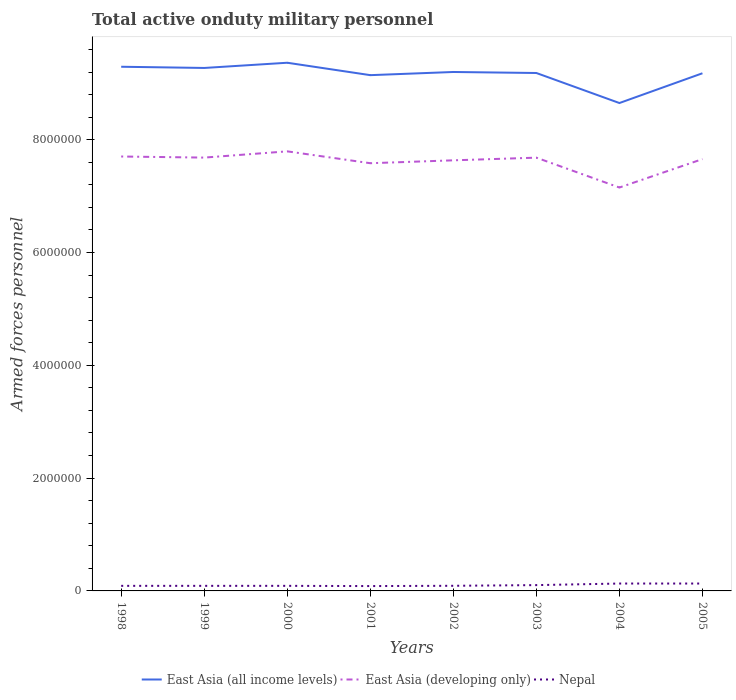Does the line corresponding to Nepal intersect with the line corresponding to East Asia (all income levels)?
Provide a short and direct response. No. Is the number of lines equal to the number of legend labels?
Make the answer very short. Yes. Across all years, what is the maximum number of armed forces personnel in East Asia (all income levels)?
Your answer should be compact. 8.65e+06. In which year was the number of armed forces personnel in East Asia (all income levels) maximum?
Give a very brief answer. 2004. What is the total number of armed forces personnel in East Asia (developing only) in the graph?
Ensure brevity in your answer.  1.12e+05. What is the difference between the highest and the second highest number of armed forces personnel in Nepal?
Offer a very short reply. 4.50e+04. What is the difference between the highest and the lowest number of armed forces personnel in East Asia (all income levels)?
Make the answer very short. 6. How many lines are there?
Ensure brevity in your answer.  3. How are the legend labels stacked?
Your answer should be compact. Horizontal. What is the title of the graph?
Provide a short and direct response. Total active onduty military personnel. What is the label or title of the X-axis?
Your response must be concise. Years. What is the label or title of the Y-axis?
Offer a terse response. Armed forces personnel. What is the Armed forces personnel in East Asia (all income levels) in 1998?
Keep it short and to the point. 9.29e+06. What is the Armed forces personnel of East Asia (developing only) in 1998?
Your answer should be compact. 7.70e+06. What is the Armed forces personnel in East Asia (all income levels) in 1999?
Offer a terse response. 9.27e+06. What is the Armed forces personnel of East Asia (developing only) in 1999?
Provide a short and direct response. 7.68e+06. What is the Armed forces personnel of Nepal in 1999?
Keep it short and to the point. 9.00e+04. What is the Armed forces personnel of East Asia (all income levels) in 2000?
Offer a very short reply. 9.36e+06. What is the Armed forces personnel in East Asia (developing only) in 2000?
Offer a terse response. 7.79e+06. What is the Armed forces personnel in East Asia (all income levels) in 2001?
Offer a very short reply. 9.14e+06. What is the Armed forces personnel of East Asia (developing only) in 2001?
Give a very brief answer. 7.58e+06. What is the Armed forces personnel in Nepal in 2001?
Provide a succinct answer. 8.60e+04. What is the Armed forces personnel of East Asia (all income levels) in 2002?
Provide a short and direct response. 9.20e+06. What is the Armed forces personnel of East Asia (developing only) in 2002?
Provide a succinct answer. 7.63e+06. What is the Armed forces personnel of Nepal in 2002?
Your response must be concise. 9.10e+04. What is the Armed forces personnel in East Asia (all income levels) in 2003?
Your answer should be compact. 9.18e+06. What is the Armed forces personnel in East Asia (developing only) in 2003?
Your response must be concise. 7.68e+06. What is the Armed forces personnel in Nepal in 2003?
Provide a succinct answer. 1.03e+05. What is the Armed forces personnel of East Asia (all income levels) in 2004?
Keep it short and to the point. 8.65e+06. What is the Armed forces personnel in East Asia (developing only) in 2004?
Your answer should be compact. 7.15e+06. What is the Armed forces personnel in Nepal in 2004?
Your answer should be compact. 1.31e+05. What is the Armed forces personnel of East Asia (all income levels) in 2005?
Your answer should be very brief. 9.18e+06. What is the Armed forces personnel in East Asia (developing only) in 2005?
Keep it short and to the point. 7.66e+06. What is the Armed forces personnel of Nepal in 2005?
Provide a short and direct response. 1.31e+05. Across all years, what is the maximum Armed forces personnel of East Asia (all income levels)?
Provide a succinct answer. 9.36e+06. Across all years, what is the maximum Armed forces personnel of East Asia (developing only)?
Your response must be concise. 7.79e+06. Across all years, what is the maximum Armed forces personnel of Nepal?
Ensure brevity in your answer.  1.31e+05. Across all years, what is the minimum Armed forces personnel in East Asia (all income levels)?
Give a very brief answer. 8.65e+06. Across all years, what is the minimum Armed forces personnel of East Asia (developing only)?
Keep it short and to the point. 7.15e+06. Across all years, what is the minimum Armed forces personnel in Nepal?
Your answer should be compact. 8.60e+04. What is the total Armed forces personnel in East Asia (all income levels) in the graph?
Ensure brevity in your answer.  7.33e+07. What is the total Armed forces personnel of East Asia (developing only) in the graph?
Your response must be concise. 6.09e+07. What is the total Armed forces personnel in Nepal in the graph?
Your answer should be very brief. 8.12e+05. What is the difference between the Armed forces personnel of East Asia (all income levels) in 1998 and that in 1999?
Offer a very short reply. 2.13e+04. What is the difference between the Armed forces personnel of East Asia (developing only) in 1998 and that in 1999?
Ensure brevity in your answer.  1.93e+04. What is the difference between the Armed forces personnel of East Asia (all income levels) in 1998 and that in 2000?
Offer a very short reply. -7.12e+04. What is the difference between the Armed forces personnel in East Asia (developing only) in 1998 and that in 2000?
Your answer should be very brief. -9.14e+04. What is the difference between the Armed forces personnel in East Asia (all income levels) in 1998 and that in 2001?
Ensure brevity in your answer.  1.49e+05. What is the difference between the Armed forces personnel in East Asia (developing only) in 1998 and that in 2001?
Provide a succinct answer. 1.19e+05. What is the difference between the Armed forces personnel of Nepal in 1998 and that in 2001?
Provide a succinct answer. 4000. What is the difference between the Armed forces personnel of East Asia (all income levels) in 1998 and that in 2002?
Offer a terse response. 9.26e+04. What is the difference between the Armed forces personnel in East Asia (developing only) in 1998 and that in 2002?
Your answer should be compact. 6.78e+04. What is the difference between the Armed forces personnel of Nepal in 1998 and that in 2002?
Offer a very short reply. -1000. What is the difference between the Armed forces personnel of East Asia (all income levels) in 1998 and that in 2003?
Your response must be concise. 1.11e+05. What is the difference between the Armed forces personnel of East Asia (developing only) in 1998 and that in 2003?
Offer a terse response. 2.04e+04. What is the difference between the Armed forces personnel of Nepal in 1998 and that in 2003?
Keep it short and to the point. -1.30e+04. What is the difference between the Armed forces personnel in East Asia (all income levels) in 1998 and that in 2004?
Ensure brevity in your answer.  6.43e+05. What is the difference between the Armed forces personnel of East Asia (developing only) in 1998 and that in 2004?
Keep it short and to the point. 5.50e+05. What is the difference between the Armed forces personnel of Nepal in 1998 and that in 2004?
Provide a short and direct response. -4.10e+04. What is the difference between the Armed forces personnel of East Asia (all income levels) in 1998 and that in 2005?
Offer a very short reply. 1.15e+05. What is the difference between the Armed forces personnel of East Asia (developing only) in 1998 and that in 2005?
Make the answer very short. 4.62e+04. What is the difference between the Armed forces personnel in Nepal in 1998 and that in 2005?
Your answer should be compact. -4.10e+04. What is the difference between the Armed forces personnel of East Asia (all income levels) in 1999 and that in 2000?
Provide a succinct answer. -9.25e+04. What is the difference between the Armed forces personnel of East Asia (developing only) in 1999 and that in 2000?
Provide a short and direct response. -1.11e+05. What is the difference between the Armed forces personnel in Nepal in 1999 and that in 2000?
Provide a succinct answer. 0. What is the difference between the Armed forces personnel of East Asia (all income levels) in 1999 and that in 2001?
Offer a terse response. 1.27e+05. What is the difference between the Armed forces personnel of East Asia (developing only) in 1999 and that in 2001?
Your response must be concise. 9.96e+04. What is the difference between the Armed forces personnel in Nepal in 1999 and that in 2001?
Your response must be concise. 4000. What is the difference between the Armed forces personnel in East Asia (all income levels) in 1999 and that in 2002?
Keep it short and to the point. 7.13e+04. What is the difference between the Armed forces personnel in East Asia (developing only) in 1999 and that in 2002?
Ensure brevity in your answer.  4.84e+04. What is the difference between the Armed forces personnel of Nepal in 1999 and that in 2002?
Make the answer very short. -1000. What is the difference between the Armed forces personnel of East Asia (all income levels) in 1999 and that in 2003?
Offer a very short reply. 8.93e+04. What is the difference between the Armed forces personnel in East Asia (developing only) in 1999 and that in 2003?
Make the answer very short. 1050. What is the difference between the Armed forces personnel in Nepal in 1999 and that in 2003?
Provide a short and direct response. -1.30e+04. What is the difference between the Armed forces personnel in East Asia (all income levels) in 1999 and that in 2004?
Ensure brevity in your answer.  6.22e+05. What is the difference between the Armed forces personnel of East Asia (developing only) in 1999 and that in 2004?
Your response must be concise. 5.31e+05. What is the difference between the Armed forces personnel of Nepal in 1999 and that in 2004?
Keep it short and to the point. -4.10e+04. What is the difference between the Armed forces personnel of East Asia (all income levels) in 1999 and that in 2005?
Provide a succinct answer. 9.41e+04. What is the difference between the Armed forces personnel of East Asia (developing only) in 1999 and that in 2005?
Your answer should be compact. 2.68e+04. What is the difference between the Armed forces personnel in Nepal in 1999 and that in 2005?
Make the answer very short. -4.10e+04. What is the difference between the Armed forces personnel of East Asia (all income levels) in 2000 and that in 2001?
Your response must be concise. 2.20e+05. What is the difference between the Armed forces personnel of East Asia (developing only) in 2000 and that in 2001?
Provide a succinct answer. 2.10e+05. What is the difference between the Armed forces personnel in Nepal in 2000 and that in 2001?
Your answer should be very brief. 4000. What is the difference between the Armed forces personnel in East Asia (all income levels) in 2000 and that in 2002?
Offer a very short reply. 1.64e+05. What is the difference between the Armed forces personnel in East Asia (developing only) in 2000 and that in 2002?
Your answer should be compact. 1.59e+05. What is the difference between the Armed forces personnel of Nepal in 2000 and that in 2002?
Your response must be concise. -1000. What is the difference between the Armed forces personnel of East Asia (all income levels) in 2000 and that in 2003?
Ensure brevity in your answer.  1.82e+05. What is the difference between the Armed forces personnel in East Asia (developing only) in 2000 and that in 2003?
Provide a succinct answer. 1.12e+05. What is the difference between the Armed forces personnel in Nepal in 2000 and that in 2003?
Provide a short and direct response. -1.30e+04. What is the difference between the Armed forces personnel of East Asia (all income levels) in 2000 and that in 2004?
Make the answer very short. 7.14e+05. What is the difference between the Armed forces personnel in East Asia (developing only) in 2000 and that in 2004?
Make the answer very short. 6.41e+05. What is the difference between the Armed forces personnel in Nepal in 2000 and that in 2004?
Provide a short and direct response. -4.10e+04. What is the difference between the Armed forces personnel of East Asia (all income levels) in 2000 and that in 2005?
Your response must be concise. 1.87e+05. What is the difference between the Armed forces personnel of East Asia (developing only) in 2000 and that in 2005?
Provide a short and direct response. 1.38e+05. What is the difference between the Armed forces personnel in Nepal in 2000 and that in 2005?
Give a very brief answer. -4.10e+04. What is the difference between the Armed forces personnel in East Asia (all income levels) in 2001 and that in 2002?
Your answer should be very brief. -5.62e+04. What is the difference between the Armed forces personnel of East Asia (developing only) in 2001 and that in 2002?
Offer a terse response. -5.12e+04. What is the difference between the Armed forces personnel in Nepal in 2001 and that in 2002?
Your answer should be very brief. -5000. What is the difference between the Armed forces personnel in East Asia (all income levels) in 2001 and that in 2003?
Ensure brevity in your answer.  -3.82e+04. What is the difference between the Armed forces personnel of East Asia (developing only) in 2001 and that in 2003?
Your answer should be very brief. -9.86e+04. What is the difference between the Armed forces personnel in Nepal in 2001 and that in 2003?
Your answer should be compact. -1.70e+04. What is the difference between the Armed forces personnel in East Asia (all income levels) in 2001 and that in 2004?
Make the answer very short. 4.94e+05. What is the difference between the Armed forces personnel in East Asia (developing only) in 2001 and that in 2004?
Ensure brevity in your answer.  4.31e+05. What is the difference between the Armed forces personnel of Nepal in 2001 and that in 2004?
Offer a terse response. -4.50e+04. What is the difference between the Armed forces personnel in East Asia (all income levels) in 2001 and that in 2005?
Make the answer very short. -3.34e+04. What is the difference between the Armed forces personnel of East Asia (developing only) in 2001 and that in 2005?
Offer a very short reply. -7.28e+04. What is the difference between the Armed forces personnel in Nepal in 2001 and that in 2005?
Give a very brief answer. -4.50e+04. What is the difference between the Armed forces personnel in East Asia (all income levels) in 2002 and that in 2003?
Provide a short and direct response. 1.80e+04. What is the difference between the Armed forces personnel in East Asia (developing only) in 2002 and that in 2003?
Ensure brevity in your answer.  -4.74e+04. What is the difference between the Armed forces personnel of Nepal in 2002 and that in 2003?
Make the answer very short. -1.20e+04. What is the difference between the Armed forces personnel in East Asia (all income levels) in 2002 and that in 2004?
Keep it short and to the point. 5.51e+05. What is the difference between the Armed forces personnel in East Asia (developing only) in 2002 and that in 2004?
Provide a short and direct response. 4.82e+05. What is the difference between the Armed forces personnel of East Asia (all income levels) in 2002 and that in 2005?
Keep it short and to the point. 2.28e+04. What is the difference between the Armed forces personnel in East Asia (developing only) in 2002 and that in 2005?
Offer a terse response. -2.16e+04. What is the difference between the Armed forces personnel of Nepal in 2002 and that in 2005?
Your answer should be compact. -4.00e+04. What is the difference between the Armed forces personnel in East Asia (all income levels) in 2003 and that in 2004?
Your response must be concise. 5.33e+05. What is the difference between the Armed forces personnel of East Asia (developing only) in 2003 and that in 2004?
Give a very brief answer. 5.30e+05. What is the difference between the Armed forces personnel in Nepal in 2003 and that in 2004?
Offer a terse response. -2.80e+04. What is the difference between the Armed forces personnel in East Asia (all income levels) in 2003 and that in 2005?
Provide a succinct answer. 4800. What is the difference between the Armed forces personnel in East Asia (developing only) in 2003 and that in 2005?
Your answer should be very brief. 2.58e+04. What is the difference between the Armed forces personnel in Nepal in 2003 and that in 2005?
Provide a succinct answer. -2.80e+04. What is the difference between the Armed forces personnel in East Asia (all income levels) in 2004 and that in 2005?
Make the answer very short. -5.28e+05. What is the difference between the Armed forces personnel in East Asia (developing only) in 2004 and that in 2005?
Ensure brevity in your answer.  -5.04e+05. What is the difference between the Armed forces personnel in East Asia (all income levels) in 1998 and the Armed forces personnel in East Asia (developing only) in 1999?
Offer a very short reply. 1.61e+06. What is the difference between the Armed forces personnel in East Asia (all income levels) in 1998 and the Armed forces personnel in Nepal in 1999?
Give a very brief answer. 9.20e+06. What is the difference between the Armed forces personnel in East Asia (developing only) in 1998 and the Armed forces personnel in Nepal in 1999?
Your response must be concise. 7.61e+06. What is the difference between the Armed forces personnel of East Asia (all income levels) in 1998 and the Armed forces personnel of East Asia (developing only) in 2000?
Give a very brief answer. 1.50e+06. What is the difference between the Armed forces personnel in East Asia (all income levels) in 1998 and the Armed forces personnel in Nepal in 2000?
Offer a very short reply. 9.20e+06. What is the difference between the Armed forces personnel in East Asia (developing only) in 1998 and the Armed forces personnel in Nepal in 2000?
Provide a succinct answer. 7.61e+06. What is the difference between the Armed forces personnel of East Asia (all income levels) in 1998 and the Armed forces personnel of East Asia (developing only) in 2001?
Provide a short and direct response. 1.71e+06. What is the difference between the Armed forces personnel of East Asia (all income levels) in 1998 and the Armed forces personnel of Nepal in 2001?
Ensure brevity in your answer.  9.21e+06. What is the difference between the Armed forces personnel in East Asia (developing only) in 1998 and the Armed forces personnel in Nepal in 2001?
Provide a short and direct response. 7.62e+06. What is the difference between the Armed forces personnel of East Asia (all income levels) in 1998 and the Armed forces personnel of East Asia (developing only) in 2002?
Your answer should be very brief. 1.66e+06. What is the difference between the Armed forces personnel of East Asia (all income levels) in 1998 and the Armed forces personnel of Nepal in 2002?
Offer a terse response. 9.20e+06. What is the difference between the Armed forces personnel in East Asia (developing only) in 1998 and the Armed forces personnel in Nepal in 2002?
Your response must be concise. 7.61e+06. What is the difference between the Armed forces personnel of East Asia (all income levels) in 1998 and the Armed forces personnel of East Asia (developing only) in 2003?
Your answer should be very brief. 1.61e+06. What is the difference between the Armed forces personnel in East Asia (all income levels) in 1998 and the Armed forces personnel in Nepal in 2003?
Offer a terse response. 9.19e+06. What is the difference between the Armed forces personnel in East Asia (developing only) in 1998 and the Armed forces personnel in Nepal in 2003?
Your answer should be compact. 7.60e+06. What is the difference between the Armed forces personnel of East Asia (all income levels) in 1998 and the Armed forces personnel of East Asia (developing only) in 2004?
Provide a short and direct response. 2.14e+06. What is the difference between the Armed forces personnel of East Asia (all income levels) in 1998 and the Armed forces personnel of Nepal in 2004?
Offer a very short reply. 9.16e+06. What is the difference between the Armed forces personnel of East Asia (developing only) in 1998 and the Armed forces personnel of Nepal in 2004?
Offer a terse response. 7.57e+06. What is the difference between the Armed forces personnel in East Asia (all income levels) in 1998 and the Armed forces personnel in East Asia (developing only) in 2005?
Provide a succinct answer. 1.64e+06. What is the difference between the Armed forces personnel in East Asia (all income levels) in 1998 and the Armed forces personnel in Nepal in 2005?
Keep it short and to the point. 9.16e+06. What is the difference between the Armed forces personnel in East Asia (developing only) in 1998 and the Armed forces personnel in Nepal in 2005?
Your answer should be compact. 7.57e+06. What is the difference between the Armed forces personnel in East Asia (all income levels) in 1999 and the Armed forces personnel in East Asia (developing only) in 2000?
Give a very brief answer. 1.48e+06. What is the difference between the Armed forces personnel of East Asia (all income levels) in 1999 and the Armed forces personnel of Nepal in 2000?
Your response must be concise. 9.18e+06. What is the difference between the Armed forces personnel in East Asia (developing only) in 1999 and the Armed forces personnel in Nepal in 2000?
Provide a succinct answer. 7.59e+06. What is the difference between the Armed forces personnel of East Asia (all income levels) in 1999 and the Armed forces personnel of East Asia (developing only) in 2001?
Your answer should be very brief. 1.69e+06. What is the difference between the Armed forces personnel of East Asia (all income levels) in 1999 and the Armed forces personnel of Nepal in 2001?
Ensure brevity in your answer.  9.19e+06. What is the difference between the Armed forces personnel in East Asia (developing only) in 1999 and the Armed forces personnel in Nepal in 2001?
Your answer should be compact. 7.60e+06. What is the difference between the Armed forces personnel of East Asia (all income levels) in 1999 and the Armed forces personnel of East Asia (developing only) in 2002?
Provide a short and direct response. 1.64e+06. What is the difference between the Armed forces personnel in East Asia (all income levels) in 1999 and the Armed forces personnel in Nepal in 2002?
Offer a terse response. 9.18e+06. What is the difference between the Armed forces personnel in East Asia (developing only) in 1999 and the Armed forces personnel in Nepal in 2002?
Provide a succinct answer. 7.59e+06. What is the difference between the Armed forces personnel of East Asia (all income levels) in 1999 and the Armed forces personnel of East Asia (developing only) in 2003?
Offer a very short reply. 1.59e+06. What is the difference between the Armed forces personnel in East Asia (all income levels) in 1999 and the Armed forces personnel in Nepal in 2003?
Provide a succinct answer. 9.17e+06. What is the difference between the Armed forces personnel in East Asia (developing only) in 1999 and the Armed forces personnel in Nepal in 2003?
Make the answer very short. 7.58e+06. What is the difference between the Armed forces personnel of East Asia (all income levels) in 1999 and the Armed forces personnel of East Asia (developing only) in 2004?
Make the answer very short. 2.12e+06. What is the difference between the Armed forces personnel of East Asia (all income levels) in 1999 and the Armed forces personnel of Nepal in 2004?
Provide a succinct answer. 9.14e+06. What is the difference between the Armed forces personnel in East Asia (developing only) in 1999 and the Armed forces personnel in Nepal in 2004?
Offer a terse response. 7.55e+06. What is the difference between the Armed forces personnel of East Asia (all income levels) in 1999 and the Armed forces personnel of East Asia (developing only) in 2005?
Keep it short and to the point. 1.62e+06. What is the difference between the Armed forces personnel in East Asia (all income levels) in 1999 and the Armed forces personnel in Nepal in 2005?
Make the answer very short. 9.14e+06. What is the difference between the Armed forces personnel in East Asia (developing only) in 1999 and the Armed forces personnel in Nepal in 2005?
Provide a succinct answer. 7.55e+06. What is the difference between the Armed forces personnel of East Asia (all income levels) in 2000 and the Armed forces personnel of East Asia (developing only) in 2001?
Your answer should be compact. 1.78e+06. What is the difference between the Armed forces personnel in East Asia (all income levels) in 2000 and the Armed forces personnel in Nepal in 2001?
Make the answer very short. 9.28e+06. What is the difference between the Armed forces personnel in East Asia (developing only) in 2000 and the Armed forces personnel in Nepal in 2001?
Make the answer very short. 7.71e+06. What is the difference between the Armed forces personnel of East Asia (all income levels) in 2000 and the Armed forces personnel of East Asia (developing only) in 2002?
Provide a succinct answer. 1.73e+06. What is the difference between the Armed forces personnel in East Asia (all income levels) in 2000 and the Armed forces personnel in Nepal in 2002?
Provide a succinct answer. 9.27e+06. What is the difference between the Armed forces personnel of East Asia (developing only) in 2000 and the Armed forces personnel of Nepal in 2002?
Your answer should be compact. 7.70e+06. What is the difference between the Armed forces personnel in East Asia (all income levels) in 2000 and the Armed forces personnel in East Asia (developing only) in 2003?
Offer a very short reply. 1.68e+06. What is the difference between the Armed forces personnel of East Asia (all income levels) in 2000 and the Armed forces personnel of Nepal in 2003?
Provide a short and direct response. 9.26e+06. What is the difference between the Armed forces personnel in East Asia (developing only) in 2000 and the Armed forces personnel in Nepal in 2003?
Ensure brevity in your answer.  7.69e+06. What is the difference between the Armed forces personnel of East Asia (all income levels) in 2000 and the Armed forces personnel of East Asia (developing only) in 2004?
Give a very brief answer. 2.21e+06. What is the difference between the Armed forces personnel of East Asia (all income levels) in 2000 and the Armed forces personnel of Nepal in 2004?
Your answer should be compact. 9.23e+06. What is the difference between the Armed forces personnel of East Asia (developing only) in 2000 and the Armed forces personnel of Nepal in 2004?
Your answer should be compact. 7.66e+06. What is the difference between the Armed forces personnel in East Asia (all income levels) in 2000 and the Armed forces personnel in East Asia (developing only) in 2005?
Make the answer very short. 1.71e+06. What is the difference between the Armed forces personnel in East Asia (all income levels) in 2000 and the Armed forces personnel in Nepal in 2005?
Your answer should be very brief. 9.23e+06. What is the difference between the Armed forces personnel in East Asia (developing only) in 2000 and the Armed forces personnel in Nepal in 2005?
Offer a very short reply. 7.66e+06. What is the difference between the Armed forces personnel in East Asia (all income levels) in 2001 and the Armed forces personnel in East Asia (developing only) in 2002?
Your answer should be compact. 1.51e+06. What is the difference between the Armed forces personnel in East Asia (all income levels) in 2001 and the Armed forces personnel in Nepal in 2002?
Your answer should be compact. 9.05e+06. What is the difference between the Armed forces personnel in East Asia (developing only) in 2001 and the Armed forces personnel in Nepal in 2002?
Your response must be concise. 7.49e+06. What is the difference between the Armed forces personnel of East Asia (all income levels) in 2001 and the Armed forces personnel of East Asia (developing only) in 2003?
Provide a succinct answer. 1.46e+06. What is the difference between the Armed forces personnel of East Asia (all income levels) in 2001 and the Armed forces personnel of Nepal in 2003?
Provide a short and direct response. 9.04e+06. What is the difference between the Armed forces personnel of East Asia (developing only) in 2001 and the Armed forces personnel of Nepal in 2003?
Keep it short and to the point. 7.48e+06. What is the difference between the Armed forces personnel of East Asia (all income levels) in 2001 and the Armed forces personnel of East Asia (developing only) in 2004?
Offer a terse response. 1.99e+06. What is the difference between the Armed forces personnel in East Asia (all income levels) in 2001 and the Armed forces personnel in Nepal in 2004?
Give a very brief answer. 9.01e+06. What is the difference between the Armed forces personnel of East Asia (developing only) in 2001 and the Armed forces personnel of Nepal in 2004?
Make the answer very short. 7.45e+06. What is the difference between the Armed forces personnel in East Asia (all income levels) in 2001 and the Armed forces personnel in East Asia (developing only) in 2005?
Make the answer very short. 1.49e+06. What is the difference between the Armed forces personnel in East Asia (all income levels) in 2001 and the Armed forces personnel in Nepal in 2005?
Your answer should be very brief. 9.01e+06. What is the difference between the Armed forces personnel of East Asia (developing only) in 2001 and the Armed forces personnel of Nepal in 2005?
Offer a terse response. 7.45e+06. What is the difference between the Armed forces personnel of East Asia (all income levels) in 2002 and the Armed forces personnel of East Asia (developing only) in 2003?
Give a very brief answer. 1.52e+06. What is the difference between the Armed forces personnel in East Asia (all income levels) in 2002 and the Armed forces personnel in Nepal in 2003?
Your response must be concise. 9.10e+06. What is the difference between the Armed forces personnel of East Asia (developing only) in 2002 and the Armed forces personnel of Nepal in 2003?
Give a very brief answer. 7.53e+06. What is the difference between the Armed forces personnel in East Asia (all income levels) in 2002 and the Armed forces personnel in East Asia (developing only) in 2004?
Offer a very short reply. 2.05e+06. What is the difference between the Armed forces personnel in East Asia (all income levels) in 2002 and the Armed forces personnel in Nepal in 2004?
Keep it short and to the point. 9.07e+06. What is the difference between the Armed forces personnel in East Asia (developing only) in 2002 and the Armed forces personnel in Nepal in 2004?
Make the answer very short. 7.50e+06. What is the difference between the Armed forces personnel in East Asia (all income levels) in 2002 and the Armed forces personnel in East Asia (developing only) in 2005?
Your response must be concise. 1.54e+06. What is the difference between the Armed forces personnel of East Asia (all income levels) in 2002 and the Armed forces personnel of Nepal in 2005?
Your answer should be compact. 9.07e+06. What is the difference between the Armed forces personnel in East Asia (developing only) in 2002 and the Armed forces personnel in Nepal in 2005?
Ensure brevity in your answer.  7.50e+06. What is the difference between the Armed forces personnel of East Asia (all income levels) in 2003 and the Armed forces personnel of East Asia (developing only) in 2004?
Provide a short and direct response. 2.03e+06. What is the difference between the Armed forces personnel of East Asia (all income levels) in 2003 and the Armed forces personnel of Nepal in 2004?
Offer a very short reply. 9.05e+06. What is the difference between the Armed forces personnel of East Asia (developing only) in 2003 and the Armed forces personnel of Nepal in 2004?
Keep it short and to the point. 7.55e+06. What is the difference between the Armed forces personnel in East Asia (all income levels) in 2003 and the Armed forces personnel in East Asia (developing only) in 2005?
Your response must be concise. 1.53e+06. What is the difference between the Armed forces personnel in East Asia (all income levels) in 2003 and the Armed forces personnel in Nepal in 2005?
Make the answer very short. 9.05e+06. What is the difference between the Armed forces personnel in East Asia (developing only) in 2003 and the Armed forces personnel in Nepal in 2005?
Provide a succinct answer. 7.55e+06. What is the difference between the Armed forces personnel in East Asia (all income levels) in 2004 and the Armed forces personnel in East Asia (developing only) in 2005?
Provide a succinct answer. 9.94e+05. What is the difference between the Armed forces personnel in East Asia (all income levels) in 2004 and the Armed forces personnel in Nepal in 2005?
Your response must be concise. 8.52e+06. What is the difference between the Armed forces personnel in East Asia (developing only) in 2004 and the Armed forces personnel in Nepal in 2005?
Your answer should be compact. 7.02e+06. What is the average Armed forces personnel in East Asia (all income levels) per year?
Keep it short and to the point. 9.16e+06. What is the average Armed forces personnel of East Asia (developing only) per year?
Provide a succinct answer. 7.61e+06. What is the average Armed forces personnel of Nepal per year?
Your answer should be compact. 1.02e+05. In the year 1998, what is the difference between the Armed forces personnel of East Asia (all income levels) and Armed forces personnel of East Asia (developing only)?
Keep it short and to the point. 1.59e+06. In the year 1998, what is the difference between the Armed forces personnel in East Asia (all income levels) and Armed forces personnel in Nepal?
Your answer should be very brief. 9.20e+06. In the year 1998, what is the difference between the Armed forces personnel of East Asia (developing only) and Armed forces personnel of Nepal?
Your response must be concise. 7.61e+06. In the year 1999, what is the difference between the Armed forces personnel in East Asia (all income levels) and Armed forces personnel in East Asia (developing only)?
Provide a succinct answer. 1.59e+06. In the year 1999, what is the difference between the Armed forces personnel in East Asia (all income levels) and Armed forces personnel in Nepal?
Your answer should be compact. 9.18e+06. In the year 1999, what is the difference between the Armed forces personnel in East Asia (developing only) and Armed forces personnel in Nepal?
Keep it short and to the point. 7.59e+06. In the year 2000, what is the difference between the Armed forces personnel of East Asia (all income levels) and Armed forces personnel of East Asia (developing only)?
Offer a terse response. 1.57e+06. In the year 2000, what is the difference between the Armed forces personnel of East Asia (all income levels) and Armed forces personnel of Nepal?
Give a very brief answer. 9.27e+06. In the year 2000, what is the difference between the Armed forces personnel in East Asia (developing only) and Armed forces personnel in Nepal?
Provide a short and direct response. 7.70e+06. In the year 2001, what is the difference between the Armed forces personnel of East Asia (all income levels) and Armed forces personnel of East Asia (developing only)?
Keep it short and to the point. 1.56e+06. In the year 2001, what is the difference between the Armed forces personnel in East Asia (all income levels) and Armed forces personnel in Nepal?
Provide a succinct answer. 9.06e+06. In the year 2001, what is the difference between the Armed forces personnel in East Asia (developing only) and Armed forces personnel in Nepal?
Your response must be concise. 7.50e+06. In the year 2002, what is the difference between the Armed forces personnel of East Asia (all income levels) and Armed forces personnel of East Asia (developing only)?
Keep it short and to the point. 1.57e+06. In the year 2002, what is the difference between the Armed forces personnel of East Asia (all income levels) and Armed forces personnel of Nepal?
Provide a short and direct response. 9.11e+06. In the year 2002, what is the difference between the Armed forces personnel of East Asia (developing only) and Armed forces personnel of Nepal?
Provide a short and direct response. 7.54e+06. In the year 2003, what is the difference between the Armed forces personnel of East Asia (all income levels) and Armed forces personnel of East Asia (developing only)?
Provide a succinct answer. 1.50e+06. In the year 2003, what is the difference between the Armed forces personnel in East Asia (all income levels) and Armed forces personnel in Nepal?
Your response must be concise. 9.08e+06. In the year 2003, what is the difference between the Armed forces personnel of East Asia (developing only) and Armed forces personnel of Nepal?
Offer a terse response. 7.58e+06. In the year 2004, what is the difference between the Armed forces personnel of East Asia (all income levels) and Armed forces personnel of East Asia (developing only)?
Provide a succinct answer. 1.50e+06. In the year 2004, what is the difference between the Armed forces personnel in East Asia (all income levels) and Armed forces personnel in Nepal?
Your response must be concise. 8.52e+06. In the year 2004, what is the difference between the Armed forces personnel of East Asia (developing only) and Armed forces personnel of Nepal?
Make the answer very short. 7.02e+06. In the year 2005, what is the difference between the Armed forces personnel in East Asia (all income levels) and Armed forces personnel in East Asia (developing only)?
Provide a succinct answer. 1.52e+06. In the year 2005, what is the difference between the Armed forces personnel of East Asia (all income levels) and Armed forces personnel of Nepal?
Keep it short and to the point. 9.05e+06. In the year 2005, what is the difference between the Armed forces personnel in East Asia (developing only) and Armed forces personnel in Nepal?
Ensure brevity in your answer.  7.52e+06. What is the ratio of the Armed forces personnel of East Asia (all income levels) in 1998 to that in 1999?
Keep it short and to the point. 1. What is the ratio of the Armed forces personnel in East Asia (developing only) in 1998 to that in 1999?
Keep it short and to the point. 1. What is the ratio of the Armed forces personnel in East Asia (all income levels) in 1998 to that in 2000?
Offer a terse response. 0.99. What is the ratio of the Armed forces personnel in East Asia (developing only) in 1998 to that in 2000?
Your answer should be compact. 0.99. What is the ratio of the Armed forces personnel of Nepal in 1998 to that in 2000?
Provide a short and direct response. 1. What is the ratio of the Armed forces personnel in East Asia (all income levels) in 1998 to that in 2001?
Offer a terse response. 1.02. What is the ratio of the Armed forces personnel of East Asia (developing only) in 1998 to that in 2001?
Your response must be concise. 1.02. What is the ratio of the Armed forces personnel of Nepal in 1998 to that in 2001?
Provide a short and direct response. 1.05. What is the ratio of the Armed forces personnel of East Asia (all income levels) in 1998 to that in 2002?
Make the answer very short. 1.01. What is the ratio of the Armed forces personnel of East Asia (developing only) in 1998 to that in 2002?
Your response must be concise. 1.01. What is the ratio of the Armed forces personnel of East Asia (all income levels) in 1998 to that in 2003?
Offer a terse response. 1.01. What is the ratio of the Armed forces personnel of East Asia (developing only) in 1998 to that in 2003?
Keep it short and to the point. 1. What is the ratio of the Armed forces personnel in Nepal in 1998 to that in 2003?
Keep it short and to the point. 0.87. What is the ratio of the Armed forces personnel in East Asia (all income levels) in 1998 to that in 2004?
Your answer should be very brief. 1.07. What is the ratio of the Armed forces personnel of Nepal in 1998 to that in 2004?
Offer a very short reply. 0.69. What is the ratio of the Armed forces personnel in East Asia (all income levels) in 1998 to that in 2005?
Provide a succinct answer. 1.01. What is the ratio of the Armed forces personnel of East Asia (developing only) in 1998 to that in 2005?
Provide a short and direct response. 1.01. What is the ratio of the Armed forces personnel of Nepal in 1998 to that in 2005?
Offer a very short reply. 0.69. What is the ratio of the Armed forces personnel in East Asia (all income levels) in 1999 to that in 2000?
Offer a very short reply. 0.99. What is the ratio of the Armed forces personnel in East Asia (developing only) in 1999 to that in 2000?
Your answer should be compact. 0.99. What is the ratio of the Armed forces personnel of East Asia (all income levels) in 1999 to that in 2001?
Give a very brief answer. 1.01. What is the ratio of the Armed forces personnel in East Asia (developing only) in 1999 to that in 2001?
Provide a succinct answer. 1.01. What is the ratio of the Armed forces personnel of Nepal in 1999 to that in 2001?
Your answer should be compact. 1.05. What is the ratio of the Armed forces personnel in East Asia (all income levels) in 1999 to that in 2002?
Your answer should be very brief. 1.01. What is the ratio of the Armed forces personnel in East Asia (developing only) in 1999 to that in 2002?
Provide a succinct answer. 1.01. What is the ratio of the Armed forces personnel of East Asia (all income levels) in 1999 to that in 2003?
Your answer should be compact. 1.01. What is the ratio of the Armed forces personnel of East Asia (developing only) in 1999 to that in 2003?
Ensure brevity in your answer.  1. What is the ratio of the Armed forces personnel of Nepal in 1999 to that in 2003?
Ensure brevity in your answer.  0.87. What is the ratio of the Armed forces personnel in East Asia (all income levels) in 1999 to that in 2004?
Offer a very short reply. 1.07. What is the ratio of the Armed forces personnel in East Asia (developing only) in 1999 to that in 2004?
Your response must be concise. 1.07. What is the ratio of the Armed forces personnel in Nepal in 1999 to that in 2004?
Your answer should be very brief. 0.69. What is the ratio of the Armed forces personnel in East Asia (all income levels) in 1999 to that in 2005?
Give a very brief answer. 1.01. What is the ratio of the Armed forces personnel in East Asia (developing only) in 1999 to that in 2005?
Provide a short and direct response. 1. What is the ratio of the Armed forces personnel of Nepal in 1999 to that in 2005?
Provide a succinct answer. 0.69. What is the ratio of the Armed forces personnel in East Asia (all income levels) in 2000 to that in 2001?
Your answer should be compact. 1.02. What is the ratio of the Armed forces personnel of East Asia (developing only) in 2000 to that in 2001?
Provide a short and direct response. 1.03. What is the ratio of the Armed forces personnel in Nepal in 2000 to that in 2001?
Give a very brief answer. 1.05. What is the ratio of the Armed forces personnel of East Asia (all income levels) in 2000 to that in 2002?
Ensure brevity in your answer.  1.02. What is the ratio of the Armed forces personnel in East Asia (developing only) in 2000 to that in 2002?
Make the answer very short. 1.02. What is the ratio of the Armed forces personnel in Nepal in 2000 to that in 2002?
Provide a short and direct response. 0.99. What is the ratio of the Armed forces personnel of East Asia (all income levels) in 2000 to that in 2003?
Offer a very short reply. 1.02. What is the ratio of the Armed forces personnel in East Asia (developing only) in 2000 to that in 2003?
Offer a very short reply. 1.01. What is the ratio of the Armed forces personnel in Nepal in 2000 to that in 2003?
Make the answer very short. 0.87. What is the ratio of the Armed forces personnel in East Asia (all income levels) in 2000 to that in 2004?
Your response must be concise. 1.08. What is the ratio of the Armed forces personnel in East Asia (developing only) in 2000 to that in 2004?
Make the answer very short. 1.09. What is the ratio of the Armed forces personnel in Nepal in 2000 to that in 2004?
Your answer should be very brief. 0.69. What is the ratio of the Armed forces personnel of East Asia (all income levels) in 2000 to that in 2005?
Keep it short and to the point. 1.02. What is the ratio of the Armed forces personnel of East Asia (developing only) in 2000 to that in 2005?
Make the answer very short. 1.02. What is the ratio of the Armed forces personnel in Nepal in 2000 to that in 2005?
Give a very brief answer. 0.69. What is the ratio of the Armed forces personnel of East Asia (all income levels) in 2001 to that in 2002?
Your response must be concise. 0.99. What is the ratio of the Armed forces personnel of Nepal in 2001 to that in 2002?
Your answer should be very brief. 0.95. What is the ratio of the Armed forces personnel in East Asia (developing only) in 2001 to that in 2003?
Ensure brevity in your answer.  0.99. What is the ratio of the Armed forces personnel in Nepal in 2001 to that in 2003?
Your response must be concise. 0.83. What is the ratio of the Armed forces personnel of East Asia (all income levels) in 2001 to that in 2004?
Provide a short and direct response. 1.06. What is the ratio of the Armed forces personnel of East Asia (developing only) in 2001 to that in 2004?
Give a very brief answer. 1.06. What is the ratio of the Armed forces personnel of Nepal in 2001 to that in 2004?
Offer a terse response. 0.66. What is the ratio of the Armed forces personnel in East Asia (all income levels) in 2001 to that in 2005?
Keep it short and to the point. 1. What is the ratio of the Armed forces personnel of East Asia (developing only) in 2001 to that in 2005?
Your response must be concise. 0.99. What is the ratio of the Armed forces personnel in Nepal in 2001 to that in 2005?
Ensure brevity in your answer.  0.66. What is the ratio of the Armed forces personnel of East Asia (all income levels) in 2002 to that in 2003?
Offer a very short reply. 1. What is the ratio of the Armed forces personnel in Nepal in 2002 to that in 2003?
Offer a terse response. 0.88. What is the ratio of the Armed forces personnel in East Asia (all income levels) in 2002 to that in 2004?
Provide a succinct answer. 1.06. What is the ratio of the Armed forces personnel in East Asia (developing only) in 2002 to that in 2004?
Ensure brevity in your answer.  1.07. What is the ratio of the Armed forces personnel in Nepal in 2002 to that in 2004?
Offer a very short reply. 0.69. What is the ratio of the Armed forces personnel of East Asia (all income levels) in 2002 to that in 2005?
Give a very brief answer. 1. What is the ratio of the Armed forces personnel in East Asia (developing only) in 2002 to that in 2005?
Your answer should be very brief. 1. What is the ratio of the Armed forces personnel in Nepal in 2002 to that in 2005?
Provide a succinct answer. 0.69. What is the ratio of the Armed forces personnel in East Asia (all income levels) in 2003 to that in 2004?
Provide a short and direct response. 1.06. What is the ratio of the Armed forces personnel in East Asia (developing only) in 2003 to that in 2004?
Provide a succinct answer. 1.07. What is the ratio of the Armed forces personnel of Nepal in 2003 to that in 2004?
Offer a very short reply. 0.79. What is the ratio of the Armed forces personnel of East Asia (all income levels) in 2003 to that in 2005?
Provide a short and direct response. 1. What is the ratio of the Armed forces personnel in East Asia (developing only) in 2003 to that in 2005?
Ensure brevity in your answer.  1. What is the ratio of the Armed forces personnel in Nepal in 2003 to that in 2005?
Provide a short and direct response. 0.79. What is the ratio of the Armed forces personnel of East Asia (all income levels) in 2004 to that in 2005?
Provide a succinct answer. 0.94. What is the ratio of the Armed forces personnel of East Asia (developing only) in 2004 to that in 2005?
Your response must be concise. 0.93. What is the difference between the highest and the second highest Armed forces personnel of East Asia (all income levels)?
Provide a short and direct response. 7.12e+04. What is the difference between the highest and the second highest Armed forces personnel in East Asia (developing only)?
Offer a very short reply. 9.14e+04. What is the difference between the highest and the lowest Armed forces personnel of East Asia (all income levels)?
Provide a succinct answer. 7.14e+05. What is the difference between the highest and the lowest Armed forces personnel of East Asia (developing only)?
Make the answer very short. 6.41e+05. What is the difference between the highest and the lowest Armed forces personnel in Nepal?
Provide a succinct answer. 4.50e+04. 